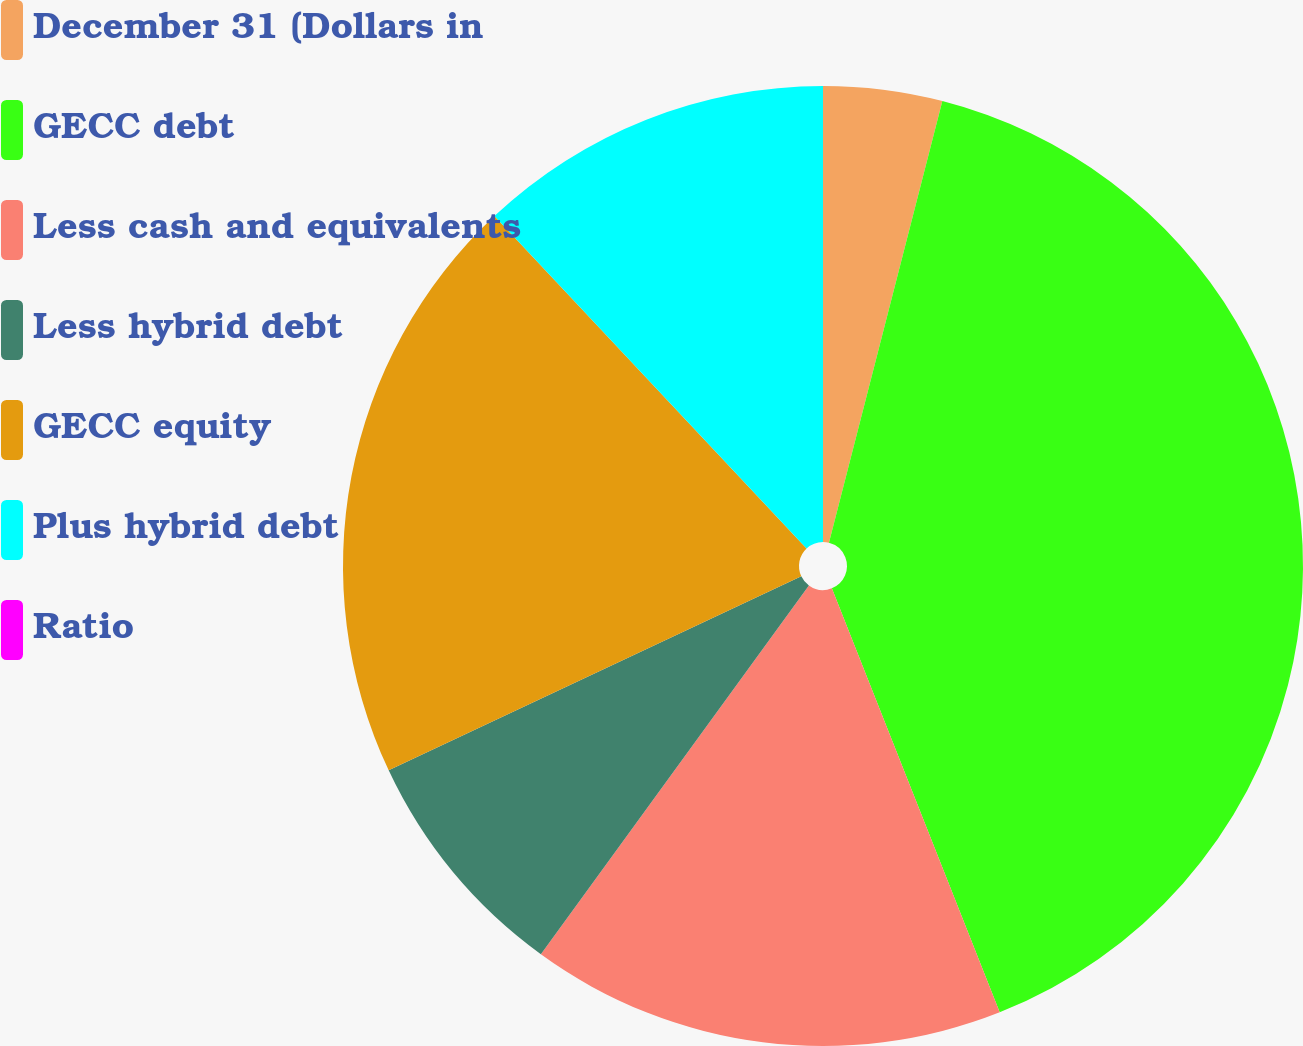Convert chart to OTSL. <chart><loc_0><loc_0><loc_500><loc_500><pie_chart><fcel>December 31 (Dollars in<fcel>GECC debt<fcel>Less cash and equivalents<fcel>Less hybrid debt<fcel>GECC equity<fcel>Plus hybrid debt<fcel>Ratio<nl><fcel>4.0%<fcel>40.0%<fcel>16.0%<fcel>8.0%<fcel>20.0%<fcel>12.0%<fcel>0.0%<nl></chart> 